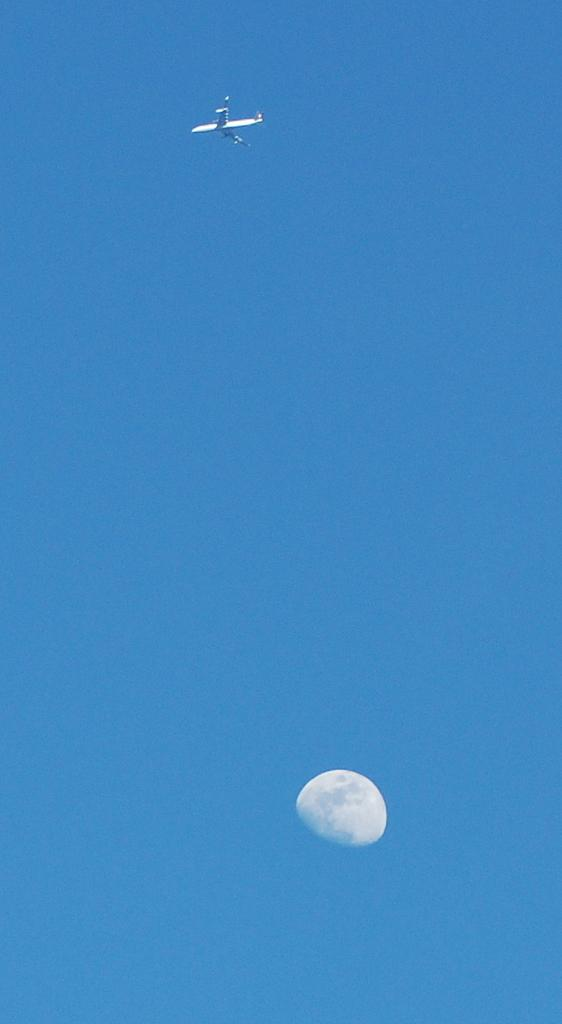What is the main subject of the image? The main subject of the image is a plane flying in the air. What can be seen below the plane in the image? The moon is visible below the plane in the image. What is the color of the sky in the image? The sky is blue in color. How many horses are holding up the base of the plane in the image? There are no horses or base present in the image; it features a plane flying in the air with the moon visible below it. 